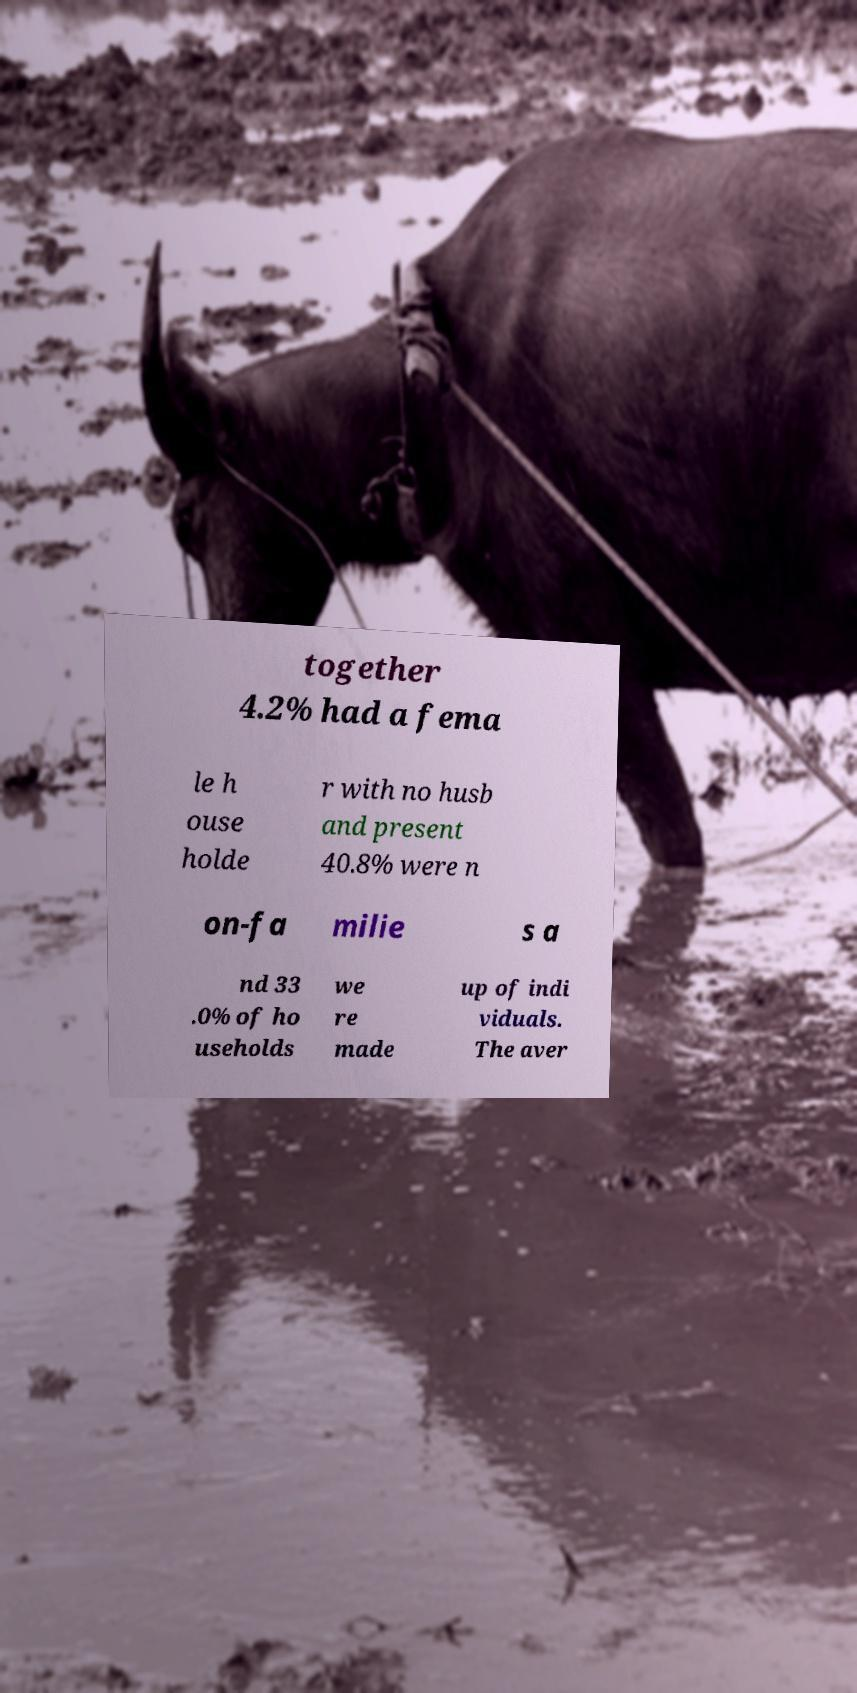Please identify and transcribe the text found in this image. together 4.2% had a fema le h ouse holde r with no husb and present 40.8% were n on-fa milie s a nd 33 .0% of ho useholds we re made up of indi viduals. The aver 